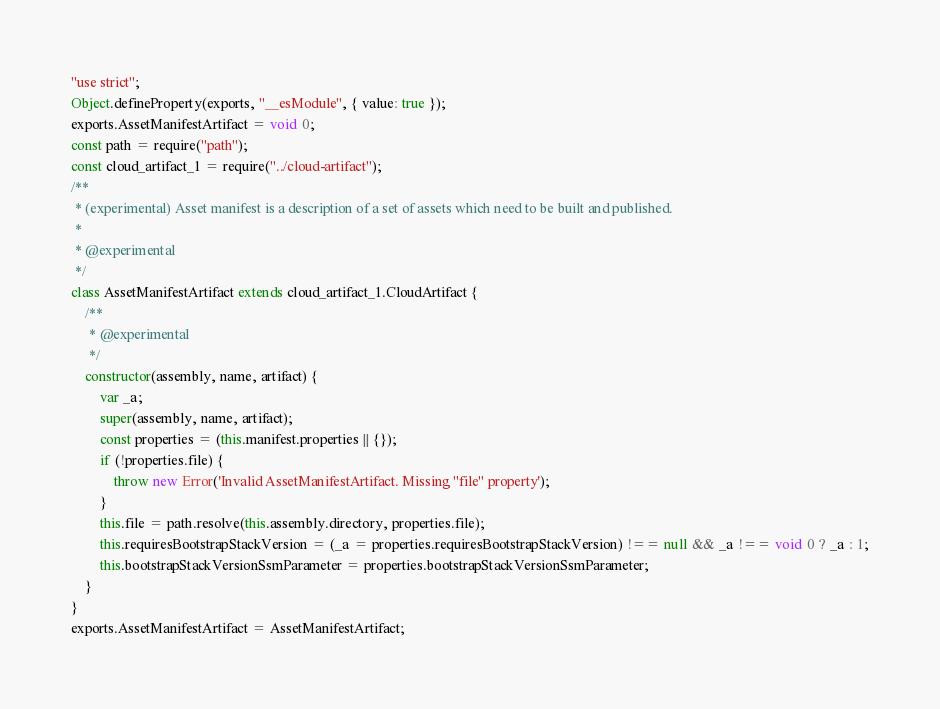Convert code to text. <code><loc_0><loc_0><loc_500><loc_500><_JavaScript_>"use strict";
Object.defineProperty(exports, "__esModule", { value: true });
exports.AssetManifestArtifact = void 0;
const path = require("path");
const cloud_artifact_1 = require("../cloud-artifact");
/**
 * (experimental) Asset manifest is a description of a set of assets which need to be built and published.
 *
 * @experimental
 */
class AssetManifestArtifact extends cloud_artifact_1.CloudArtifact {
    /**
     * @experimental
     */
    constructor(assembly, name, artifact) {
        var _a;
        super(assembly, name, artifact);
        const properties = (this.manifest.properties || {});
        if (!properties.file) {
            throw new Error('Invalid AssetManifestArtifact. Missing "file" property');
        }
        this.file = path.resolve(this.assembly.directory, properties.file);
        this.requiresBootstrapStackVersion = (_a = properties.requiresBootstrapStackVersion) !== null && _a !== void 0 ? _a : 1;
        this.bootstrapStackVersionSsmParameter = properties.bootstrapStackVersionSsmParameter;
    }
}
exports.AssetManifestArtifact = AssetManifestArtifact;</code> 